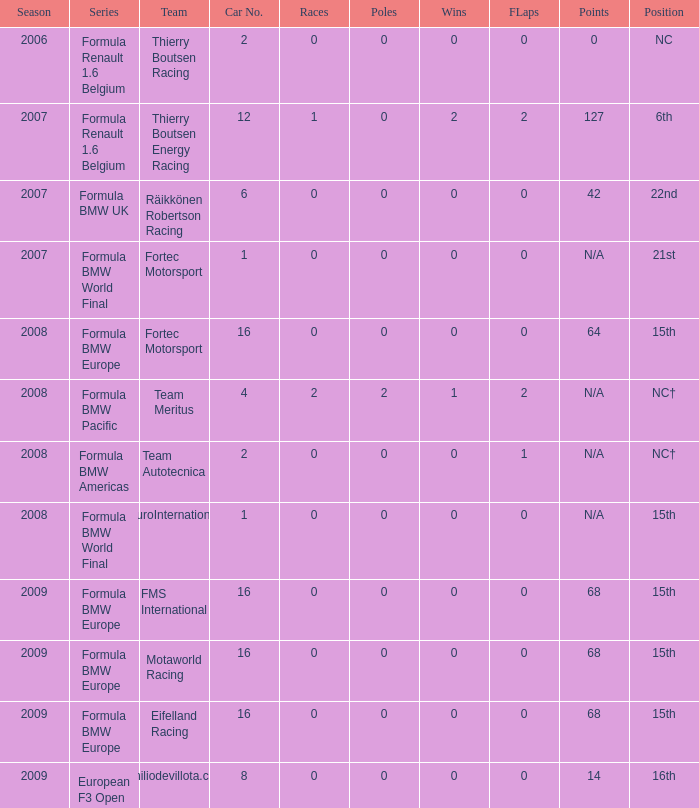Name the most poles for 64 points 0.0. 